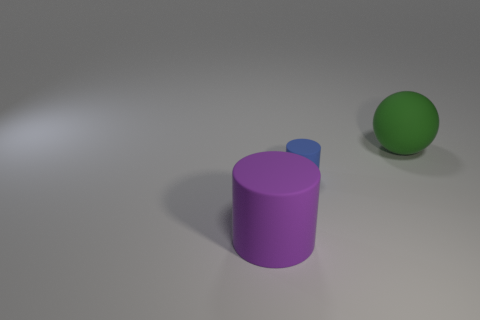Add 3 small cyan matte cylinders. How many objects exist? 6 Add 3 purple things. How many purple things are left? 4 Add 1 blue cylinders. How many blue cylinders exist? 2 Subtract 0 green blocks. How many objects are left? 3 Subtract all spheres. How many objects are left? 2 Subtract 1 spheres. How many spheres are left? 0 Subtract all blue cylinders. Subtract all purple blocks. How many cylinders are left? 1 Subtract all blue blocks. How many blue cylinders are left? 1 Subtract all tiny rubber cylinders. Subtract all large green spheres. How many objects are left? 1 